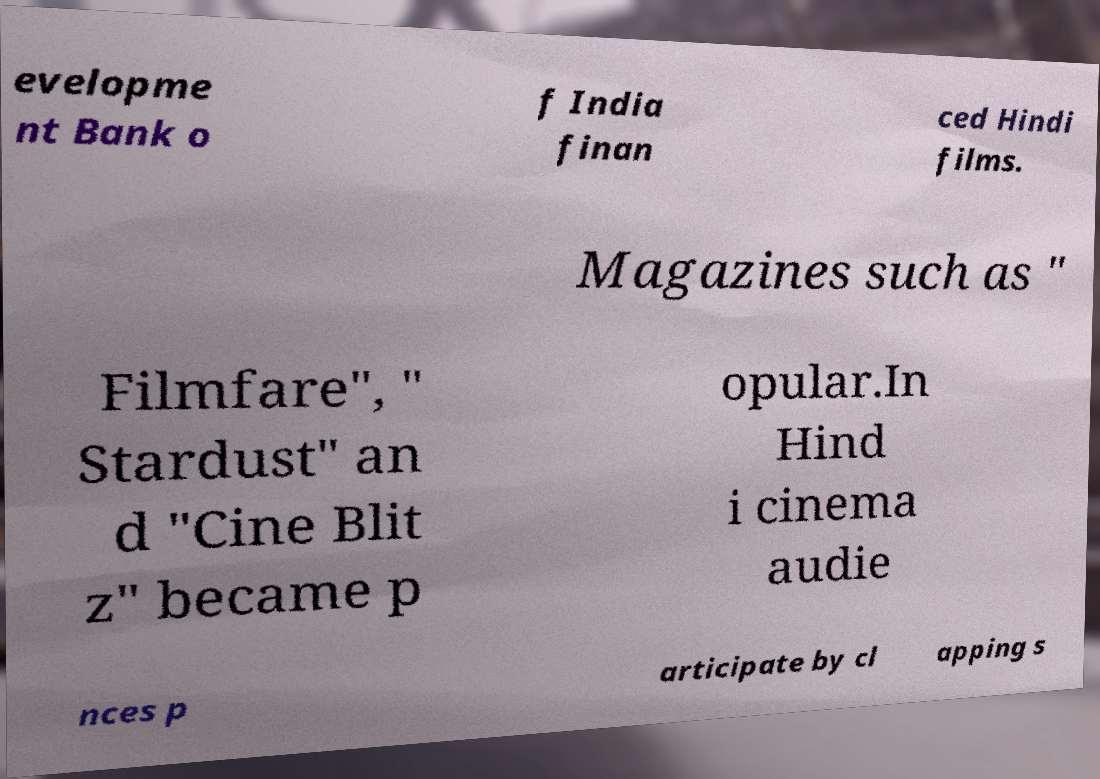Can you accurately transcribe the text from the provided image for me? evelopme nt Bank o f India finan ced Hindi films. Magazines such as " Filmfare", " Stardust" an d "Cine Blit z" became p opular.In Hind i cinema audie nces p articipate by cl apping s 